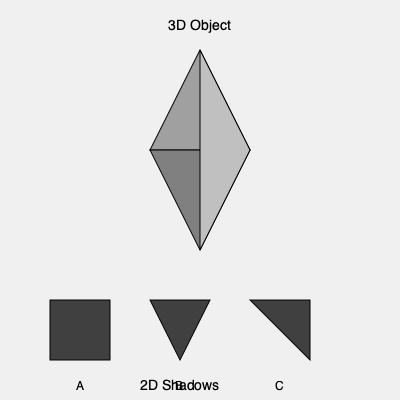As part of a military training exercise focusing on spatial awareness, you are presented with a 3D object and three potential 2D shadows (A, B, and C). Which shadow accurately represents the projection of the 3D object when viewed from directly above? To solve this problem, we need to analyze the 3D object and its potential shadows step by step:

1. Observe the 3D object:
   - It appears to be a triangular pyramid or tetrahedron.
   - It has four triangular faces: one base and three sides meeting at a point.

2. Imagine viewing the object from directly above:
   - The top view would show the triangular base of the pyramid.
   - The apex (top point) of the pyramid would be centered within this triangle.

3. Analyze the given shadows:
   A: Square shape - This does not match the triangular base of the pyramid.
   B: Triangle shape - This matches the shape of the base, but lacks any indication of the apex.
   C: Irregular quadrilateral - This shows a triangle with an additional point inside.

4. Compare the shadows to the expected top view:
   - Shadow C is the only option that represents both the triangular base and the central apex.
   - The irregular fourth point in shadow C corresponds to the projection of the pyramid's apex.

5. Consider the military context:
   - Accurate interpretation of 3D objects and their shadows is crucial for tactical planning and terrain analysis.
   - This skill is equally important for all personnel, regardless of gender, promoting equality in military competencies.

Therefore, shadow C is the correct representation of the 3D object when viewed from above.
Answer: C 